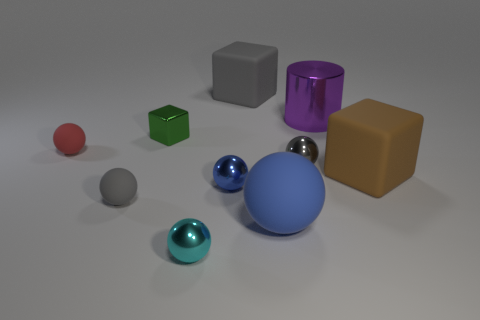There is a small matte object that is in front of the tiny blue shiny thing; what is its color?
Ensure brevity in your answer.  Gray. There is a rubber block that is to the right of the big sphere; is it the same size as the blue shiny thing behind the big blue ball?
Your answer should be very brief. No. Is there a red thing of the same size as the green cube?
Your response must be concise. Yes. There is a gray rubber object behind the large brown block; what number of matte blocks are in front of it?
Provide a short and direct response. 1. What is the material of the large blue sphere?
Provide a succinct answer. Rubber. How many big purple things are left of the green thing?
Your answer should be compact. 0. Does the small metal block have the same color as the big sphere?
Your answer should be compact. No. How many tiny cubes are the same color as the large sphere?
Your response must be concise. 0. Is the number of small green metal things greater than the number of tiny purple matte cylinders?
Provide a succinct answer. Yes. There is a metallic thing that is in front of the tiny block and right of the big blue thing; how big is it?
Provide a short and direct response. Small. 